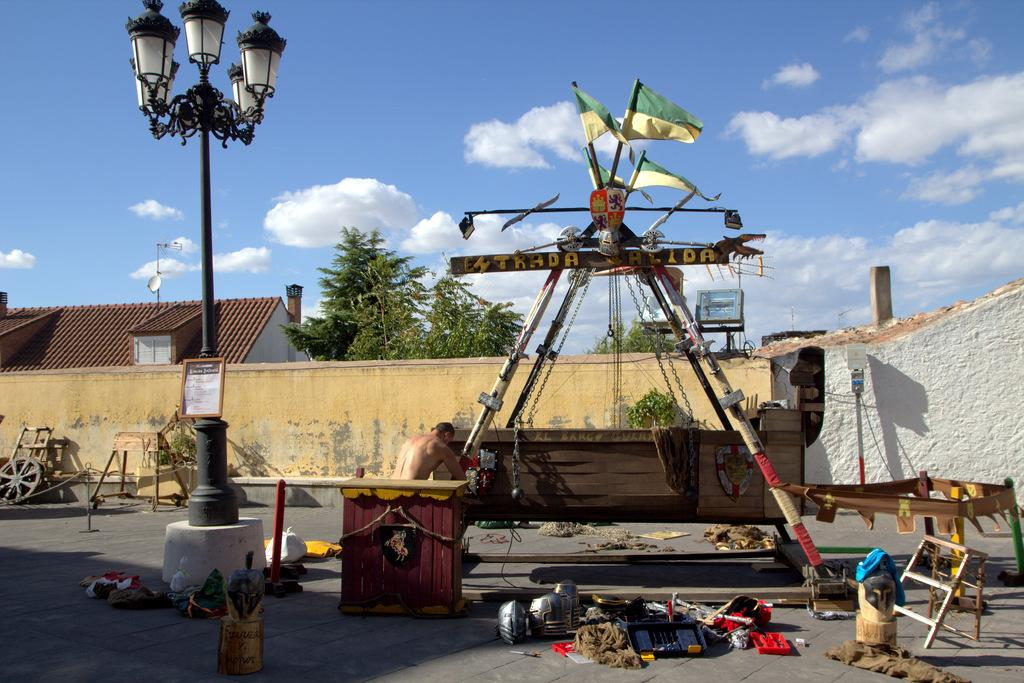What is the main subject of the image? There is a person in the image. What objects can be seen in the image besides the person? There are poles, flags, a wheel, walls, a house, trees, and some objects in the image. What is the purpose of the poles and flags in the image? The poles and flags are likely used for decoration or signaling purposes. What type of structure is the house in the image? The provided facts do not specify the type of house, but it is present in the image. What is visible in the background of the image? The sky is visible in the background of the image, with clouds present. What type of celery is being used as a chair in the image? There is no celery or chair present in the image. Who gave their approval for the objects in the image? The provided facts do not mention any approval or decision-making process related to the objects in the image. 